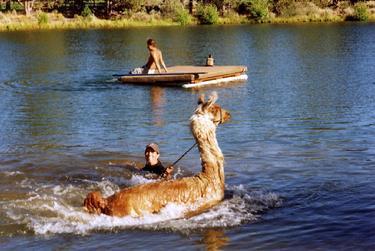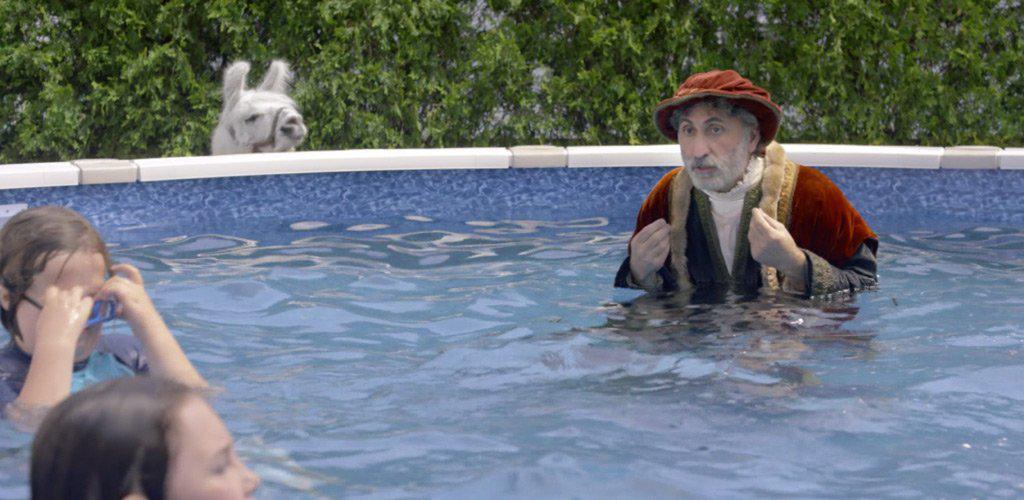The first image is the image on the left, the second image is the image on the right. Considering the images on both sides, is "An alpaca is laying down in a small blue pool in one of the pictures." valid? Answer yes or no. No. The first image is the image on the left, the second image is the image on the right. Evaluate the accuracy of this statement regarding the images: "One of the images shows an alpaca in a kiddie pool and the other image shows a llama in a lake.". Is it true? Answer yes or no. No. 